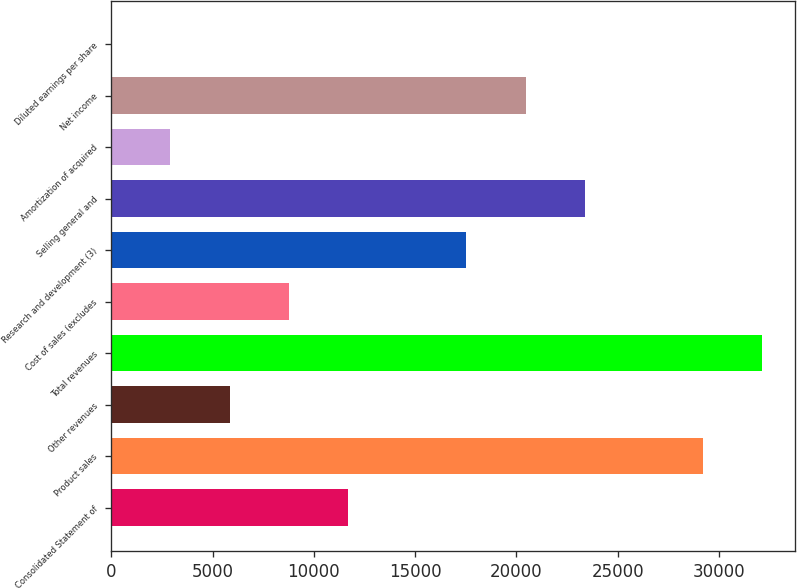Convert chart to OTSL. <chart><loc_0><loc_0><loc_500><loc_500><bar_chart><fcel>Consolidated Statement of<fcel>Product sales<fcel>Other revenues<fcel>Total revenues<fcel>Cost of sales (excludes<fcel>Research and development (3)<fcel>Selling general and<fcel>Amortization of acquired<fcel>Net income<fcel>Diluted earnings per share<nl><fcel>11689.5<fcel>29221<fcel>5845.65<fcel>32142.9<fcel>8767.57<fcel>17533.3<fcel>23377.2<fcel>2923.73<fcel>20455.2<fcel>1.81<nl></chart> 